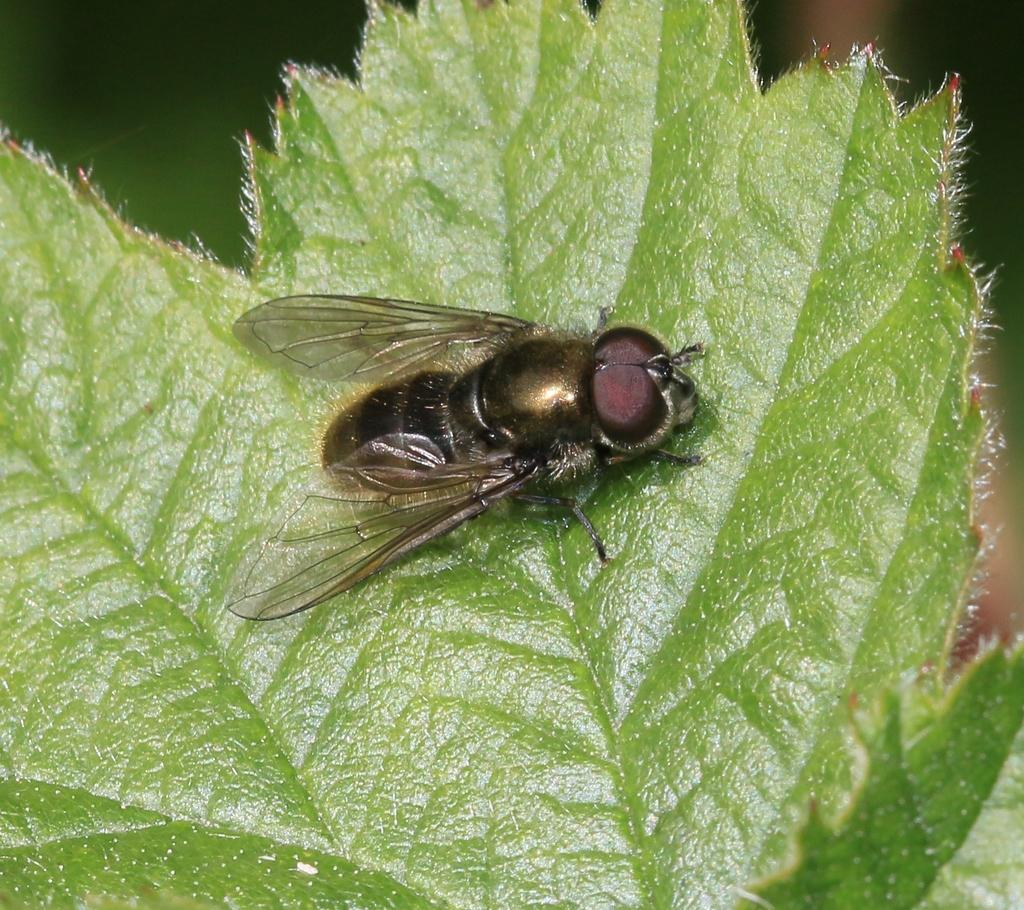What is the main subject of the image? The main subject of the image is a fly on a leaf. Can you describe the background of the image? The background of the image is blurred. How many children are playing with the machine in the image? There are no children or machines present in the image; it features a fly on a leaf with a blurred background. 